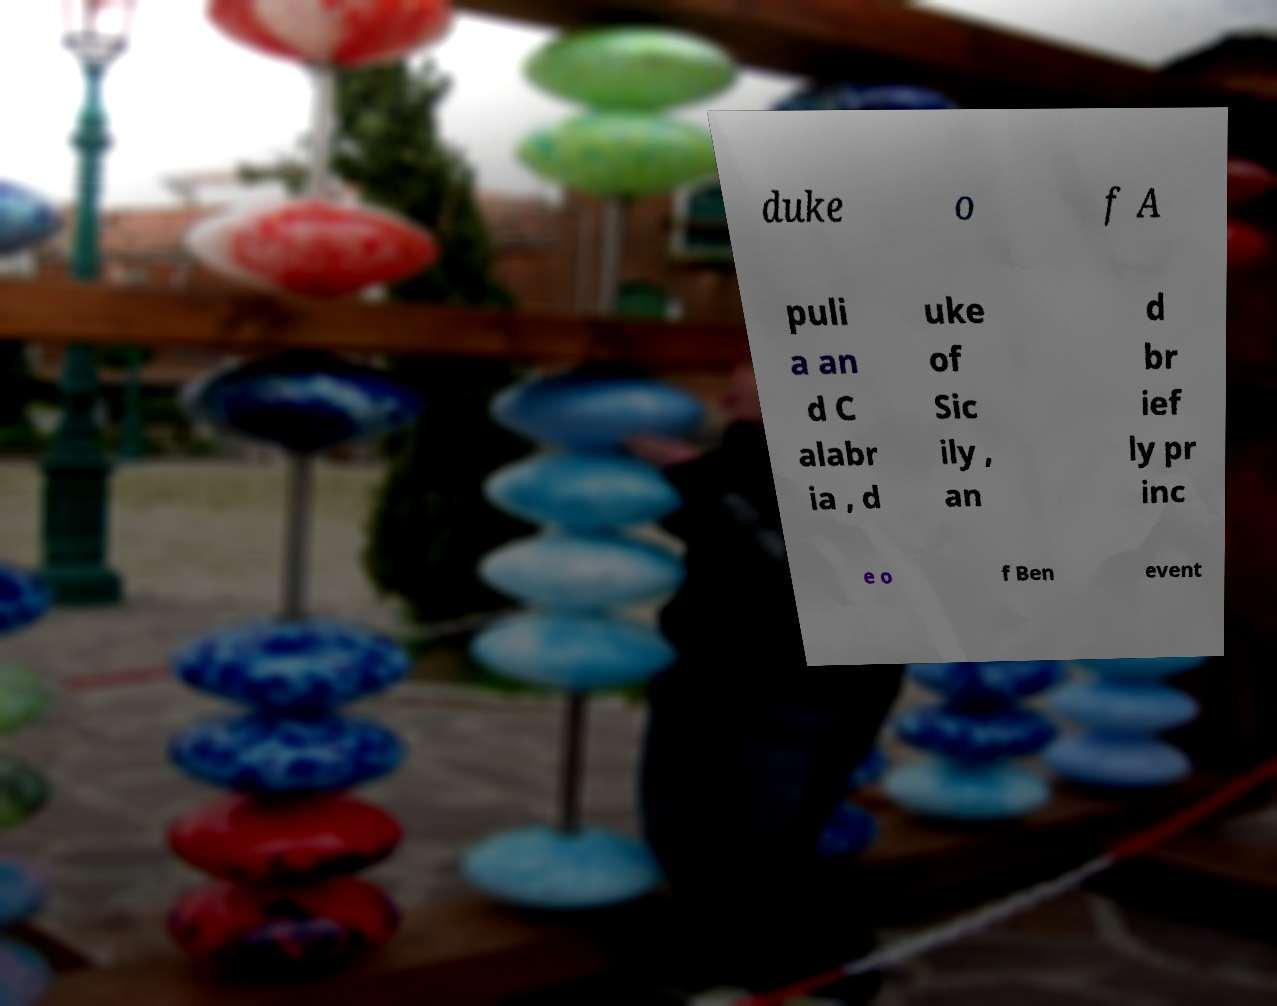For documentation purposes, I need the text within this image transcribed. Could you provide that? duke o f A puli a an d C alabr ia , d uke of Sic ily , an d br ief ly pr inc e o f Ben event 